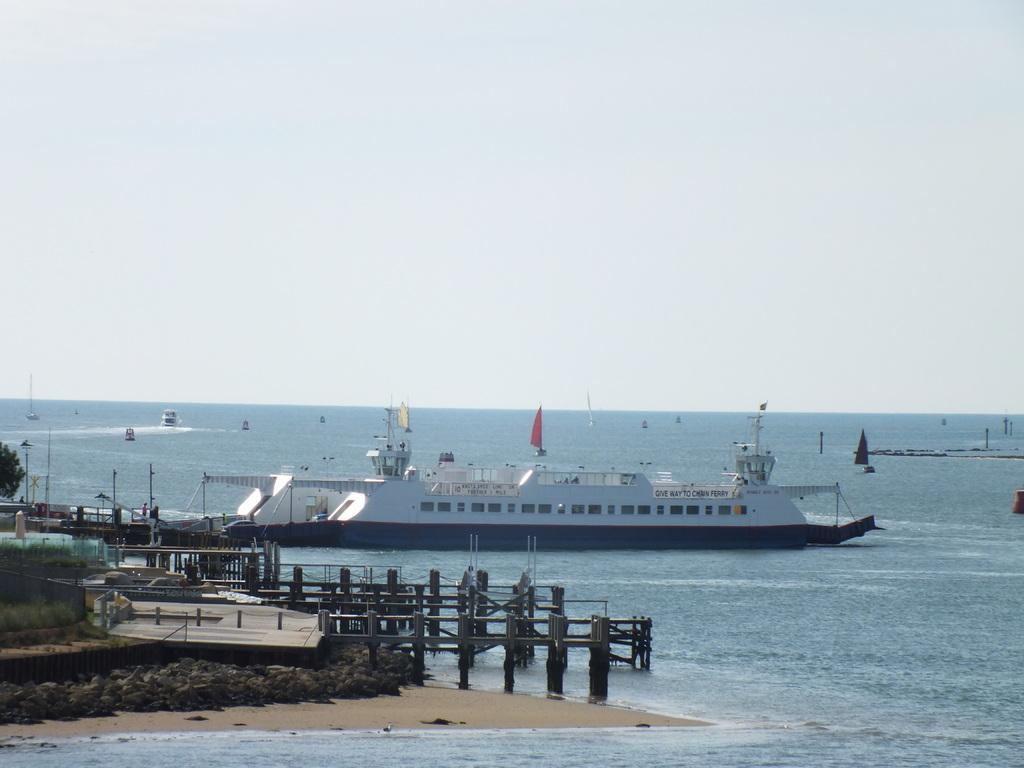In one or two sentences, can you explain what this image depicts? On the left side of the image there are wooden decks and also there are bridges with wooden walls, fencing and poles. And also there are trees and poles. And there is water. On the water there is a ship with windows. Behind the ship there are many boats and ships. At the top of the image there is sky. 